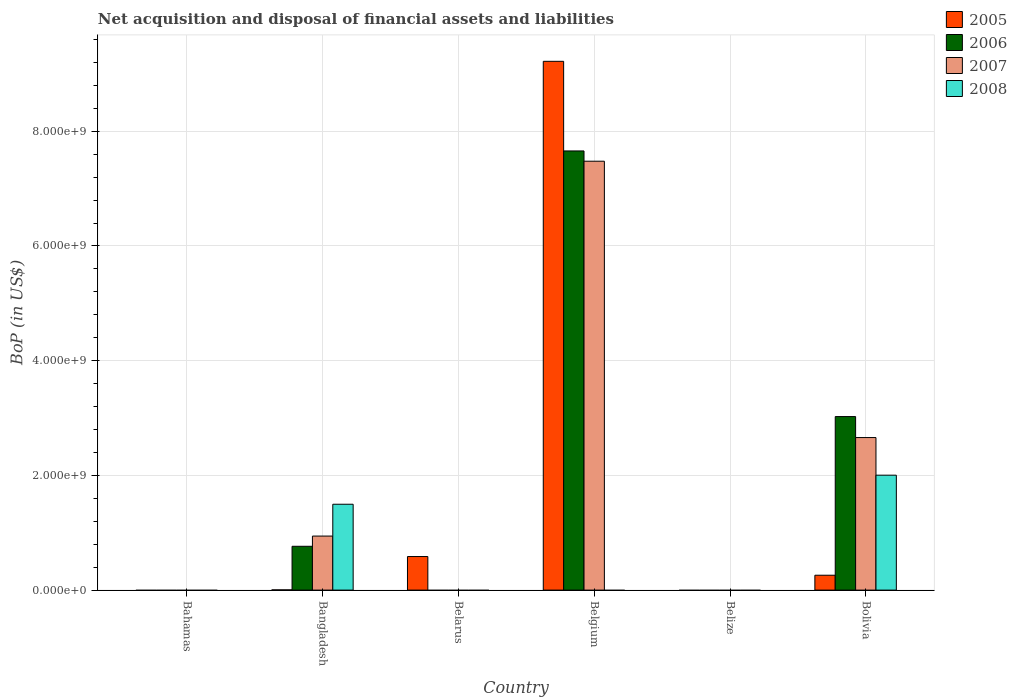How many different coloured bars are there?
Provide a short and direct response. 4. Are the number of bars on each tick of the X-axis equal?
Provide a short and direct response. No. What is the label of the 2nd group of bars from the left?
Your response must be concise. Bangladesh. In how many cases, is the number of bars for a given country not equal to the number of legend labels?
Make the answer very short. 4. Across all countries, what is the maximum Balance of Payments in 2008?
Provide a succinct answer. 2.00e+09. What is the total Balance of Payments in 2005 in the graph?
Offer a terse response. 1.01e+1. What is the difference between the Balance of Payments in 2005 in Bangladesh and that in Belgium?
Keep it short and to the point. -9.22e+09. What is the difference between the Balance of Payments in 2005 in Belize and the Balance of Payments in 2007 in Belgium?
Offer a terse response. -7.48e+09. What is the average Balance of Payments in 2006 per country?
Offer a very short reply. 1.91e+09. What is the difference between the Balance of Payments of/in 2005 and Balance of Payments of/in 2008 in Bangladesh?
Make the answer very short. -1.49e+09. In how many countries, is the Balance of Payments in 2007 greater than 8000000000 US$?
Give a very brief answer. 0. What is the ratio of the Balance of Payments in 2006 in Bangladesh to that in Bolivia?
Your answer should be very brief. 0.25. Is the Balance of Payments in 2005 in Belgium less than that in Bolivia?
Provide a short and direct response. No. What is the difference between the highest and the second highest Balance of Payments in 2006?
Provide a short and direct response. -2.26e+09. What is the difference between the highest and the lowest Balance of Payments in 2007?
Offer a very short reply. 7.48e+09. Are all the bars in the graph horizontal?
Your response must be concise. No. What is the difference between two consecutive major ticks on the Y-axis?
Your response must be concise. 2.00e+09. Are the values on the major ticks of Y-axis written in scientific E-notation?
Give a very brief answer. Yes. Does the graph contain grids?
Your response must be concise. Yes. Where does the legend appear in the graph?
Ensure brevity in your answer.  Top right. How many legend labels are there?
Offer a very short reply. 4. What is the title of the graph?
Give a very brief answer. Net acquisition and disposal of financial assets and liabilities. Does "1972" appear as one of the legend labels in the graph?
Make the answer very short. No. What is the label or title of the X-axis?
Your answer should be very brief. Country. What is the label or title of the Y-axis?
Provide a short and direct response. BoP (in US$). What is the BoP (in US$) in 2006 in Bahamas?
Your answer should be very brief. 0. What is the BoP (in US$) in 2008 in Bahamas?
Offer a very short reply. 0. What is the BoP (in US$) of 2005 in Bangladesh?
Keep it short and to the point. 3.42e+06. What is the BoP (in US$) in 2006 in Bangladesh?
Offer a very short reply. 7.64e+08. What is the BoP (in US$) in 2007 in Bangladesh?
Ensure brevity in your answer.  9.42e+08. What is the BoP (in US$) of 2008 in Bangladesh?
Keep it short and to the point. 1.50e+09. What is the BoP (in US$) of 2005 in Belarus?
Provide a short and direct response. 5.85e+08. What is the BoP (in US$) of 2005 in Belgium?
Offer a terse response. 9.22e+09. What is the BoP (in US$) in 2006 in Belgium?
Your answer should be very brief. 7.66e+09. What is the BoP (in US$) of 2007 in Belgium?
Your answer should be very brief. 7.48e+09. What is the BoP (in US$) in 2007 in Belize?
Ensure brevity in your answer.  0. What is the BoP (in US$) of 2005 in Bolivia?
Offer a very short reply. 2.59e+08. What is the BoP (in US$) in 2006 in Bolivia?
Provide a short and direct response. 3.03e+09. What is the BoP (in US$) in 2007 in Bolivia?
Offer a terse response. 2.66e+09. What is the BoP (in US$) of 2008 in Bolivia?
Provide a succinct answer. 2.00e+09. Across all countries, what is the maximum BoP (in US$) of 2005?
Give a very brief answer. 9.22e+09. Across all countries, what is the maximum BoP (in US$) of 2006?
Give a very brief answer. 7.66e+09. Across all countries, what is the maximum BoP (in US$) in 2007?
Your answer should be very brief. 7.48e+09. Across all countries, what is the maximum BoP (in US$) in 2008?
Keep it short and to the point. 2.00e+09. Across all countries, what is the minimum BoP (in US$) in 2006?
Offer a terse response. 0. Across all countries, what is the minimum BoP (in US$) of 2008?
Your answer should be compact. 0. What is the total BoP (in US$) in 2005 in the graph?
Your response must be concise. 1.01e+1. What is the total BoP (in US$) in 2006 in the graph?
Keep it short and to the point. 1.14e+1. What is the total BoP (in US$) of 2007 in the graph?
Provide a succinct answer. 1.11e+1. What is the total BoP (in US$) of 2008 in the graph?
Your answer should be very brief. 3.50e+09. What is the difference between the BoP (in US$) of 2005 in Bangladesh and that in Belarus?
Offer a terse response. -5.82e+08. What is the difference between the BoP (in US$) of 2005 in Bangladesh and that in Belgium?
Offer a terse response. -9.22e+09. What is the difference between the BoP (in US$) in 2006 in Bangladesh and that in Belgium?
Ensure brevity in your answer.  -6.89e+09. What is the difference between the BoP (in US$) in 2007 in Bangladesh and that in Belgium?
Ensure brevity in your answer.  -6.54e+09. What is the difference between the BoP (in US$) of 2005 in Bangladesh and that in Bolivia?
Your answer should be compact. -2.56e+08. What is the difference between the BoP (in US$) in 2006 in Bangladesh and that in Bolivia?
Offer a very short reply. -2.26e+09. What is the difference between the BoP (in US$) in 2007 in Bangladesh and that in Bolivia?
Ensure brevity in your answer.  -1.72e+09. What is the difference between the BoP (in US$) of 2008 in Bangladesh and that in Bolivia?
Offer a terse response. -5.07e+08. What is the difference between the BoP (in US$) in 2005 in Belarus and that in Belgium?
Provide a succinct answer. -8.63e+09. What is the difference between the BoP (in US$) of 2005 in Belarus and that in Bolivia?
Make the answer very short. 3.26e+08. What is the difference between the BoP (in US$) of 2005 in Belgium and that in Bolivia?
Provide a succinct answer. 8.96e+09. What is the difference between the BoP (in US$) in 2006 in Belgium and that in Bolivia?
Your answer should be very brief. 4.63e+09. What is the difference between the BoP (in US$) in 2007 in Belgium and that in Bolivia?
Your response must be concise. 4.82e+09. What is the difference between the BoP (in US$) in 2005 in Bangladesh and the BoP (in US$) in 2006 in Belgium?
Keep it short and to the point. -7.65e+09. What is the difference between the BoP (in US$) in 2005 in Bangladesh and the BoP (in US$) in 2007 in Belgium?
Keep it short and to the point. -7.47e+09. What is the difference between the BoP (in US$) in 2006 in Bangladesh and the BoP (in US$) in 2007 in Belgium?
Offer a very short reply. -6.71e+09. What is the difference between the BoP (in US$) of 2005 in Bangladesh and the BoP (in US$) of 2006 in Bolivia?
Give a very brief answer. -3.02e+09. What is the difference between the BoP (in US$) in 2005 in Bangladesh and the BoP (in US$) in 2007 in Bolivia?
Offer a very short reply. -2.66e+09. What is the difference between the BoP (in US$) of 2005 in Bangladesh and the BoP (in US$) of 2008 in Bolivia?
Offer a terse response. -2.00e+09. What is the difference between the BoP (in US$) in 2006 in Bangladesh and the BoP (in US$) in 2007 in Bolivia?
Offer a terse response. -1.90e+09. What is the difference between the BoP (in US$) in 2006 in Bangladesh and the BoP (in US$) in 2008 in Bolivia?
Provide a short and direct response. -1.24e+09. What is the difference between the BoP (in US$) of 2007 in Bangladesh and the BoP (in US$) of 2008 in Bolivia?
Make the answer very short. -1.06e+09. What is the difference between the BoP (in US$) of 2005 in Belarus and the BoP (in US$) of 2006 in Belgium?
Your answer should be very brief. -7.07e+09. What is the difference between the BoP (in US$) in 2005 in Belarus and the BoP (in US$) in 2007 in Belgium?
Offer a terse response. -6.89e+09. What is the difference between the BoP (in US$) in 2005 in Belarus and the BoP (in US$) in 2006 in Bolivia?
Provide a succinct answer. -2.44e+09. What is the difference between the BoP (in US$) of 2005 in Belarus and the BoP (in US$) of 2007 in Bolivia?
Ensure brevity in your answer.  -2.07e+09. What is the difference between the BoP (in US$) of 2005 in Belarus and the BoP (in US$) of 2008 in Bolivia?
Make the answer very short. -1.42e+09. What is the difference between the BoP (in US$) in 2005 in Belgium and the BoP (in US$) in 2006 in Bolivia?
Offer a very short reply. 6.19e+09. What is the difference between the BoP (in US$) in 2005 in Belgium and the BoP (in US$) in 2007 in Bolivia?
Your answer should be very brief. 6.56e+09. What is the difference between the BoP (in US$) in 2005 in Belgium and the BoP (in US$) in 2008 in Bolivia?
Your answer should be compact. 7.22e+09. What is the difference between the BoP (in US$) in 2006 in Belgium and the BoP (in US$) in 2007 in Bolivia?
Give a very brief answer. 5.00e+09. What is the difference between the BoP (in US$) in 2006 in Belgium and the BoP (in US$) in 2008 in Bolivia?
Provide a succinct answer. 5.65e+09. What is the difference between the BoP (in US$) in 2007 in Belgium and the BoP (in US$) in 2008 in Bolivia?
Your answer should be compact. 5.47e+09. What is the average BoP (in US$) of 2005 per country?
Keep it short and to the point. 1.68e+09. What is the average BoP (in US$) of 2006 per country?
Give a very brief answer. 1.91e+09. What is the average BoP (in US$) in 2007 per country?
Keep it short and to the point. 1.85e+09. What is the average BoP (in US$) of 2008 per country?
Your answer should be very brief. 5.83e+08. What is the difference between the BoP (in US$) in 2005 and BoP (in US$) in 2006 in Bangladesh?
Your answer should be compact. -7.60e+08. What is the difference between the BoP (in US$) of 2005 and BoP (in US$) of 2007 in Bangladesh?
Provide a succinct answer. -9.39e+08. What is the difference between the BoP (in US$) in 2005 and BoP (in US$) in 2008 in Bangladesh?
Offer a terse response. -1.49e+09. What is the difference between the BoP (in US$) of 2006 and BoP (in US$) of 2007 in Bangladesh?
Provide a succinct answer. -1.78e+08. What is the difference between the BoP (in US$) in 2006 and BoP (in US$) in 2008 in Bangladesh?
Your response must be concise. -7.33e+08. What is the difference between the BoP (in US$) in 2007 and BoP (in US$) in 2008 in Bangladesh?
Your answer should be very brief. -5.55e+08. What is the difference between the BoP (in US$) in 2005 and BoP (in US$) in 2006 in Belgium?
Your answer should be very brief. 1.56e+09. What is the difference between the BoP (in US$) of 2005 and BoP (in US$) of 2007 in Belgium?
Your answer should be very brief. 1.74e+09. What is the difference between the BoP (in US$) in 2006 and BoP (in US$) in 2007 in Belgium?
Make the answer very short. 1.79e+08. What is the difference between the BoP (in US$) in 2005 and BoP (in US$) in 2006 in Bolivia?
Keep it short and to the point. -2.77e+09. What is the difference between the BoP (in US$) in 2005 and BoP (in US$) in 2007 in Bolivia?
Your answer should be very brief. -2.40e+09. What is the difference between the BoP (in US$) of 2005 and BoP (in US$) of 2008 in Bolivia?
Ensure brevity in your answer.  -1.74e+09. What is the difference between the BoP (in US$) of 2006 and BoP (in US$) of 2007 in Bolivia?
Keep it short and to the point. 3.66e+08. What is the difference between the BoP (in US$) in 2006 and BoP (in US$) in 2008 in Bolivia?
Offer a terse response. 1.02e+09. What is the difference between the BoP (in US$) of 2007 and BoP (in US$) of 2008 in Bolivia?
Provide a succinct answer. 6.56e+08. What is the ratio of the BoP (in US$) of 2005 in Bangladesh to that in Belarus?
Offer a very short reply. 0.01. What is the ratio of the BoP (in US$) in 2006 in Bangladesh to that in Belgium?
Provide a short and direct response. 0.1. What is the ratio of the BoP (in US$) in 2007 in Bangladesh to that in Belgium?
Provide a succinct answer. 0.13. What is the ratio of the BoP (in US$) of 2005 in Bangladesh to that in Bolivia?
Your answer should be very brief. 0.01. What is the ratio of the BoP (in US$) in 2006 in Bangladesh to that in Bolivia?
Give a very brief answer. 0.25. What is the ratio of the BoP (in US$) of 2007 in Bangladesh to that in Bolivia?
Offer a terse response. 0.35. What is the ratio of the BoP (in US$) in 2008 in Bangladesh to that in Bolivia?
Offer a very short reply. 0.75. What is the ratio of the BoP (in US$) of 2005 in Belarus to that in Belgium?
Your response must be concise. 0.06. What is the ratio of the BoP (in US$) of 2005 in Belarus to that in Bolivia?
Your answer should be compact. 2.26. What is the ratio of the BoP (in US$) in 2005 in Belgium to that in Bolivia?
Your response must be concise. 35.55. What is the ratio of the BoP (in US$) in 2006 in Belgium to that in Bolivia?
Your answer should be compact. 2.53. What is the ratio of the BoP (in US$) in 2007 in Belgium to that in Bolivia?
Your answer should be compact. 2.81. What is the difference between the highest and the second highest BoP (in US$) in 2005?
Provide a short and direct response. 8.63e+09. What is the difference between the highest and the second highest BoP (in US$) of 2006?
Make the answer very short. 4.63e+09. What is the difference between the highest and the second highest BoP (in US$) of 2007?
Your answer should be compact. 4.82e+09. What is the difference between the highest and the lowest BoP (in US$) in 2005?
Keep it short and to the point. 9.22e+09. What is the difference between the highest and the lowest BoP (in US$) of 2006?
Give a very brief answer. 7.66e+09. What is the difference between the highest and the lowest BoP (in US$) in 2007?
Your answer should be very brief. 7.48e+09. What is the difference between the highest and the lowest BoP (in US$) in 2008?
Your answer should be compact. 2.00e+09. 